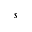Convert formula to latex. <formula><loc_0><loc_0><loc_500><loc_500>s</formula> 